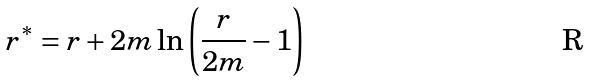<formula> <loc_0><loc_0><loc_500><loc_500>r ^ { * } = r + 2 m \ln \left ( \frac { r } { 2 m } - 1 \right )</formula> 